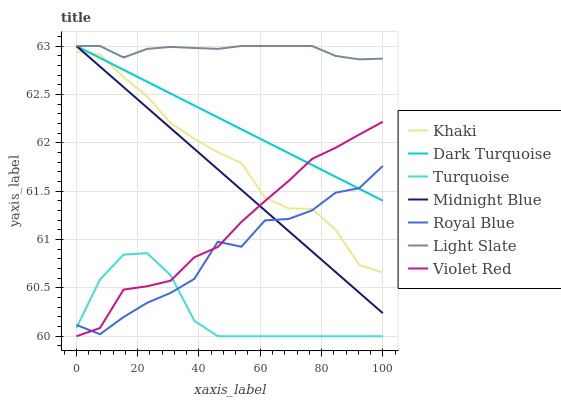Does Turquoise have the minimum area under the curve?
Answer yes or no. Yes. Does Light Slate have the maximum area under the curve?
Answer yes or no. Yes. Does Khaki have the minimum area under the curve?
Answer yes or no. No. Does Khaki have the maximum area under the curve?
Answer yes or no. No. Is Midnight Blue the smoothest?
Answer yes or no. Yes. Is Royal Blue the roughest?
Answer yes or no. Yes. Is Khaki the smoothest?
Answer yes or no. No. Is Khaki the roughest?
Answer yes or no. No. Does Turquoise have the lowest value?
Answer yes or no. Yes. Does Khaki have the lowest value?
Answer yes or no. No. Does Dark Turquoise have the highest value?
Answer yes or no. Yes. Does Khaki have the highest value?
Answer yes or no. No. Is Turquoise less than Midnight Blue?
Answer yes or no. Yes. Is Light Slate greater than Turquoise?
Answer yes or no. Yes. Does Royal Blue intersect Khaki?
Answer yes or no. Yes. Is Royal Blue less than Khaki?
Answer yes or no. No. Is Royal Blue greater than Khaki?
Answer yes or no. No. Does Turquoise intersect Midnight Blue?
Answer yes or no. No. 